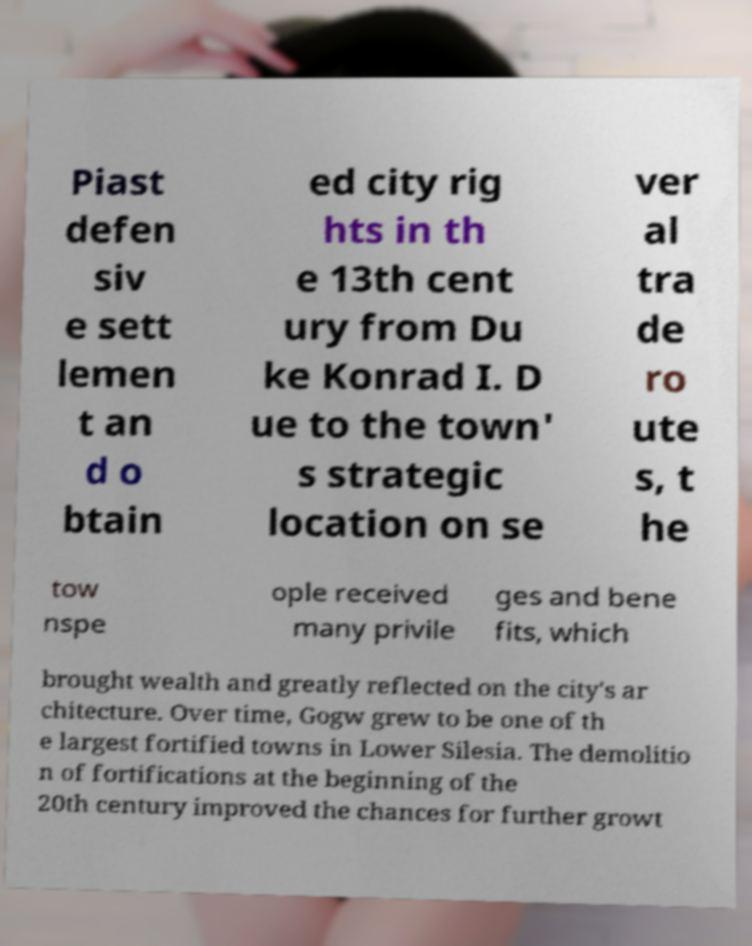Can you read and provide the text displayed in the image?This photo seems to have some interesting text. Can you extract and type it out for me? Piast defen siv e sett lemen t an d o btain ed city rig hts in th e 13th cent ury from Du ke Konrad I. D ue to the town' s strategic location on se ver al tra de ro ute s, t he tow nspe ople received many privile ges and bene fits, which brought wealth and greatly reflected on the city's ar chitecture. Over time, Gogw grew to be one of th e largest fortified towns in Lower Silesia. The demolitio n of fortifications at the beginning of the 20th century improved the chances for further growt 